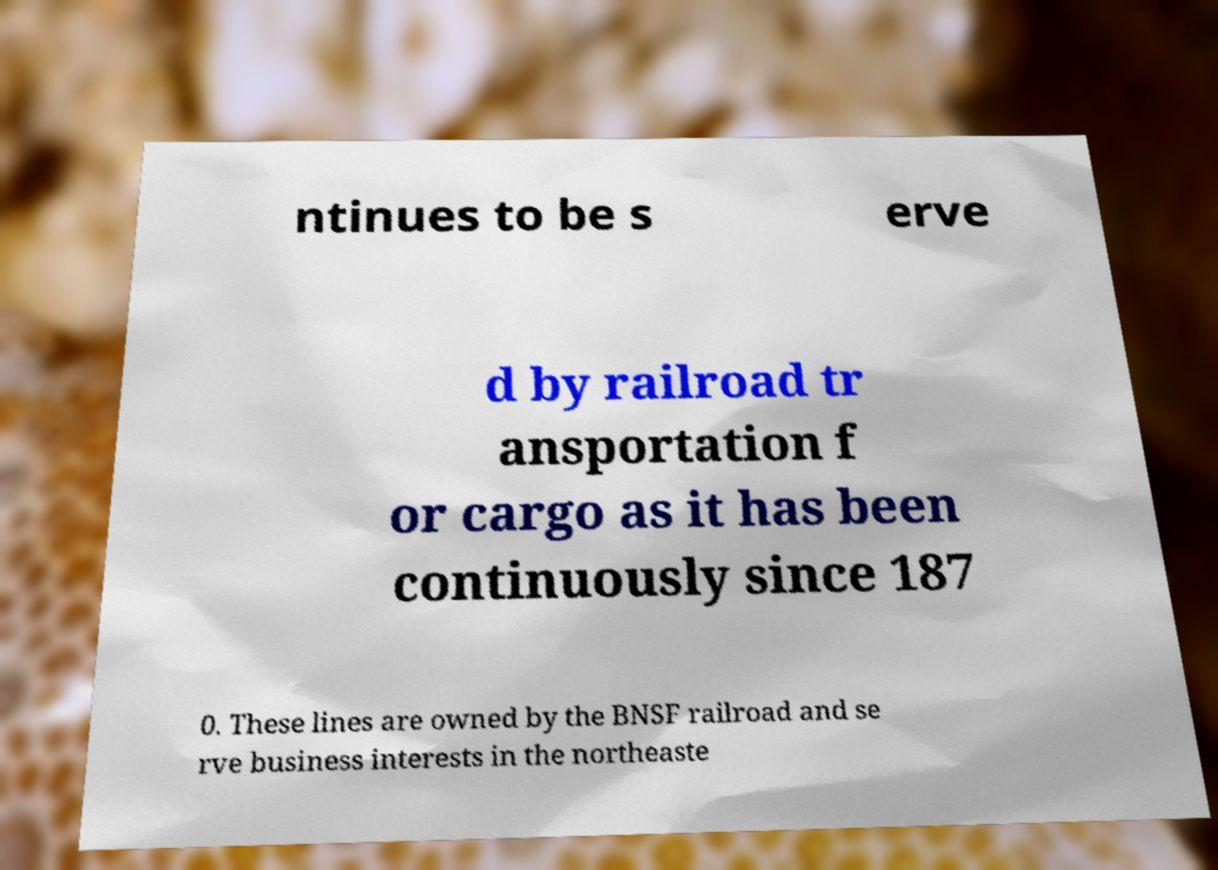Could you assist in decoding the text presented in this image and type it out clearly? ntinues to be s erve d by railroad tr ansportation f or cargo as it has been continuously since 187 0. These lines are owned by the BNSF railroad and se rve business interests in the northeaste 